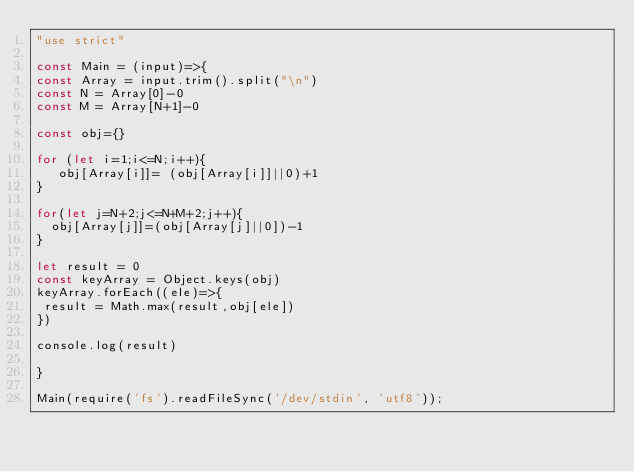Convert code to text. <code><loc_0><loc_0><loc_500><loc_500><_JavaScript_>"use strict"

const Main = (input)=>{
const Array = input.trim().split("\n")
const N = Array[0]-0
const M = Array[N+1]-0

const obj={}

for (let i=1;i<=N;i++){
   obj[Array[i]]= (obj[Array[i]]||0)+1
}

for(let j=N+2;j<=N+M+2;j++){
  obj[Array[j]]=(obj[Array[j]||0])-1
}

let result = 0
const keyArray = Object.keys(obj)
keyArray.forEach((ele)=>{
 result = Math.max(result,obj[ele])
})

console.log(result)

}

Main(require('fs').readFileSync('/dev/stdin', 'utf8'));</code> 